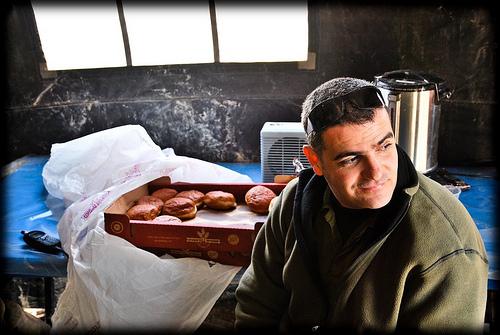What is on the man 's head?
Quick response, please. Sunglasses. Where is he looking?
Quick response, please. Left. What is on top of the man's head?
Write a very short answer. Sunglasses. Is the man smiling?
Quick response, please. Yes. What is in the box?
Short answer required. Donuts. 